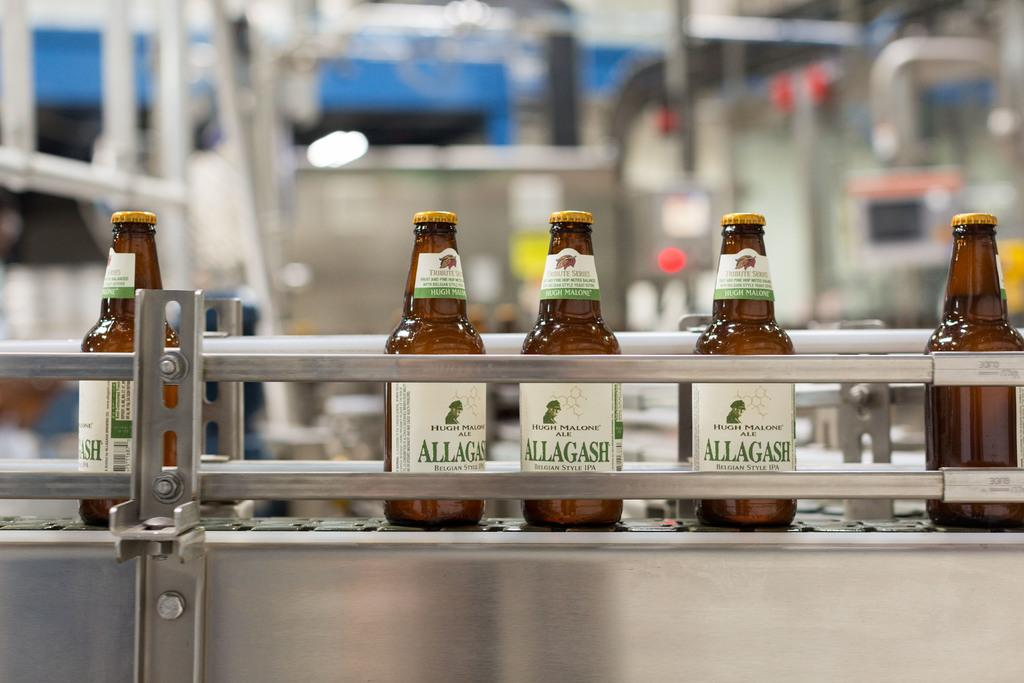Provide a one-sentence caption for the provided image. Five beers labeled Allagash sit on a factory line. 